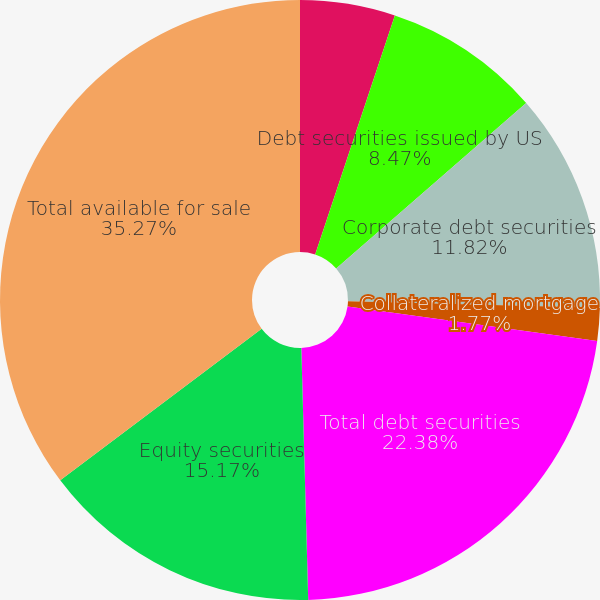Convert chart to OTSL. <chart><loc_0><loc_0><loc_500><loc_500><pie_chart><fcel>US treasury securities<fcel>Debt securities issued by US<fcel>Corporate debt securities<fcel>Collateralized mortgage<fcel>Total debt securities<fcel>Equity securities<fcel>Total available for sale<nl><fcel>5.12%<fcel>8.47%<fcel>11.82%<fcel>1.77%<fcel>22.38%<fcel>15.17%<fcel>35.26%<nl></chart> 